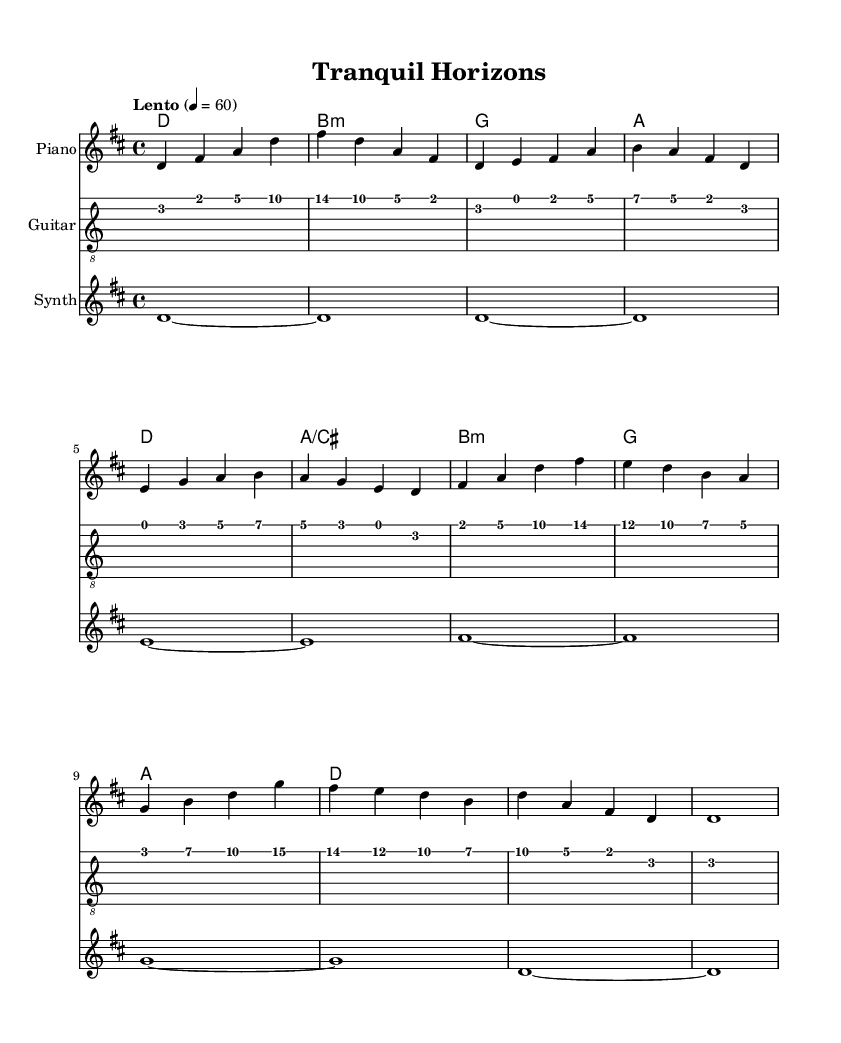What is the key signature of this music? The key signature indicates the presence of two sharps: F sharp and C sharp. This can be identified by looking at the key signature located at the beginning of the music, which shows one sharp above the staff for F sharp and another sharp on the third line for C sharp.
Answer: D major What is the time signature of this piece? The time signature is found at the beginning of the sheet music, and it indicates that there are four beats in each measure, which is shown as a 4 over 4 notation.
Answer: 4/4 What is the tempo marking for this piece? The tempo marking is indicated near the beginning of the score, and it specifies the pace of the music. The marking "Lento" suggests a slow tempo, typically described as "slowly," and the metronome marking of 60 indicates there are 60 beats per minute.
Answer: Lento How many measures are there in the piano part? By counting the distinct groups of notes separated by vertical lines on the staff, we can see there are a total of ten measures in the piano part.
Answer: Ten What is the type of instrument indicated for the first staff? The first staff in the music sheet specifies "Piano" as the instrument name, which informs the player about which instrument to use.
Answer: Piano What is the final note of the guitar part? The last note of the guitar part is identified by checking the last measure of the guitar tab and confirming the note on the staff. In this score, the final note is a long sustained note, indicated at the end, which is D, held for a whole measure.
Answer: D What are the main chord progressions used throughout the piece? Analyzing the chord symbols written above the staff, we notice the progression follows a repetitive sequence of D major, B minor, G major, and A major chords. These chords create a calming yet engaging atmosphere that's suitable for relaxation and stress relief.
Answer: D, B minor, G, A 